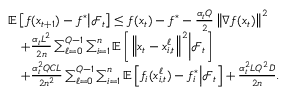Convert formula to latex. <formula><loc_0><loc_0><loc_500><loc_500>\begin{array} { r l } & { \mathbb { E } \left [ f ( x _ { t + 1 } ) - f ^ { * } | d l e | \mathcal { F } _ { t } \right ] \leq f ( x _ { t } ) - f ^ { * } - \frac { \alpha _ { t } Q } { 2 } \left \| \nabla f ( x _ { t } ) \right \| ^ { 2 } } \\ & { \quad + \frac { \alpha _ { t } L ^ { 2 } } { 2 n } \sum _ { \ell = 0 } ^ { Q - 1 } \sum _ { i = 1 } ^ { n } \mathbb { E } \left [ \left \| x _ { t } - x _ { i , t } ^ { \ell } \right \| ^ { 2 } | d l e | \mathcal { F } _ { t } \right ] } \\ & { \quad + \frac { \alpha _ { t } ^ { 2 } Q C L } { 2 n ^ { 2 } } \sum _ { \ell = 0 } ^ { Q - 1 } \sum _ { i = 1 } ^ { n } \mathbb { E } \left [ f _ { i } ( x _ { i , t } ^ { \ell } ) - f _ { i } ^ { * } | d l e | \mathcal { F } _ { t } \right ] + \frac { \alpha _ { t } ^ { 2 } L Q ^ { 2 } D } { 2 n } . } \end{array}</formula> 